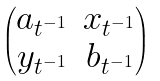Convert formula to latex. <formula><loc_0><loc_0><loc_500><loc_500>\begin{pmatrix} a _ { t ^ { - 1 } } & x _ { t ^ { - 1 } } \\ y _ { t ^ { - 1 } } & b _ { t ^ { - 1 } } \end{pmatrix}</formula> 